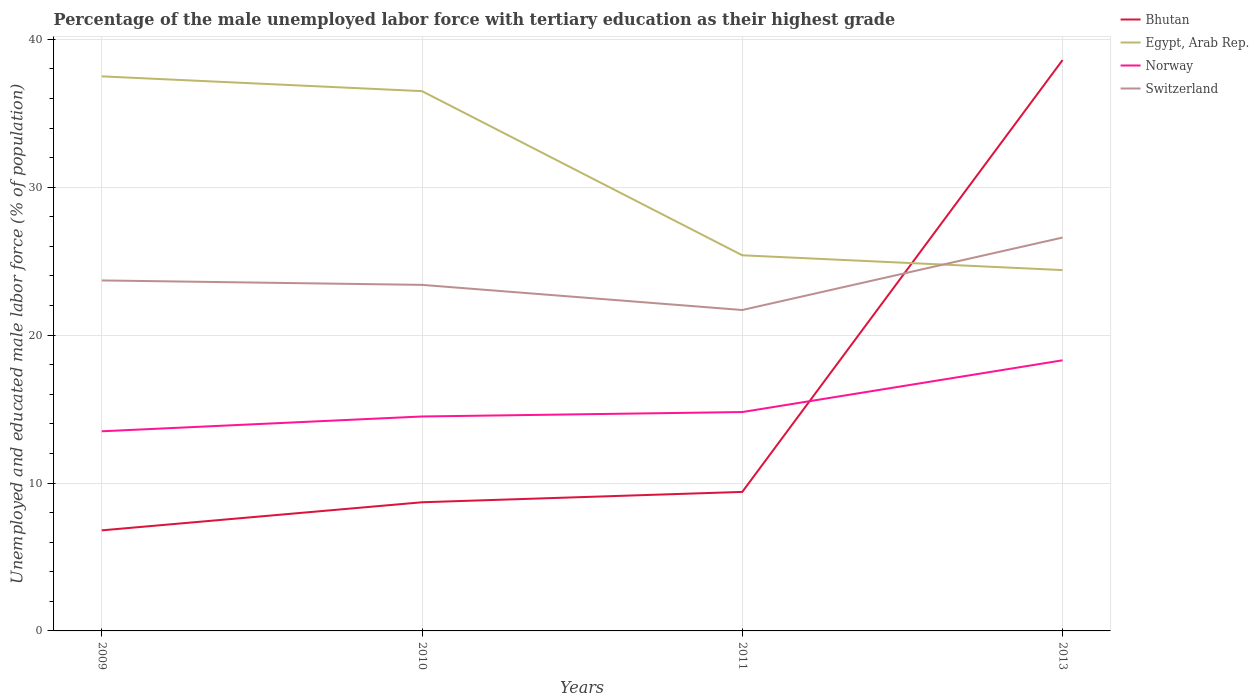How many different coloured lines are there?
Provide a short and direct response. 4. What is the total percentage of the unemployed male labor force with tertiary education in Norway in the graph?
Your answer should be very brief. -1. What is the difference between the highest and the second highest percentage of the unemployed male labor force with tertiary education in Bhutan?
Your response must be concise. 31.8. What is the difference between the highest and the lowest percentage of the unemployed male labor force with tertiary education in Norway?
Your response must be concise. 1. How many lines are there?
Ensure brevity in your answer.  4. What is the difference between two consecutive major ticks on the Y-axis?
Offer a terse response. 10. Are the values on the major ticks of Y-axis written in scientific E-notation?
Offer a very short reply. No. What is the title of the graph?
Provide a short and direct response. Percentage of the male unemployed labor force with tertiary education as their highest grade. Does "Peru" appear as one of the legend labels in the graph?
Provide a short and direct response. No. What is the label or title of the X-axis?
Provide a short and direct response. Years. What is the label or title of the Y-axis?
Keep it short and to the point. Unemployed and educated male labor force (% of population). What is the Unemployed and educated male labor force (% of population) of Bhutan in 2009?
Provide a succinct answer. 6.8. What is the Unemployed and educated male labor force (% of population) of Egypt, Arab Rep. in 2009?
Provide a short and direct response. 37.5. What is the Unemployed and educated male labor force (% of population) in Switzerland in 2009?
Offer a terse response. 23.7. What is the Unemployed and educated male labor force (% of population) of Bhutan in 2010?
Your answer should be compact. 8.7. What is the Unemployed and educated male labor force (% of population) in Egypt, Arab Rep. in 2010?
Offer a terse response. 36.5. What is the Unemployed and educated male labor force (% of population) in Switzerland in 2010?
Keep it short and to the point. 23.4. What is the Unemployed and educated male labor force (% of population) in Bhutan in 2011?
Ensure brevity in your answer.  9.4. What is the Unemployed and educated male labor force (% of population) in Egypt, Arab Rep. in 2011?
Keep it short and to the point. 25.4. What is the Unemployed and educated male labor force (% of population) of Norway in 2011?
Offer a terse response. 14.8. What is the Unemployed and educated male labor force (% of population) in Switzerland in 2011?
Keep it short and to the point. 21.7. What is the Unemployed and educated male labor force (% of population) in Bhutan in 2013?
Give a very brief answer. 38.6. What is the Unemployed and educated male labor force (% of population) in Egypt, Arab Rep. in 2013?
Provide a succinct answer. 24.4. What is the Unemployed and educated male labor force (% of population) of Norway in 2013?
Provide a short and direct response. 18.3. What is the Unemployed and educated male labor force (% of population) in Switzerland in 2013?
Provide a succinct answer. 26.6. Across all years, what is the maximum Unemployed and educated male labor force (% of population) of Bhutan?
Provide a succinct answer. 38.6. Across all years, what is the maximum Unemployed and educated male labor force (% of population) of Egypt, Arab Rep.?
Ensure brevity in your answer.  37.5. Across all years, what is the maximum Unemployed and educated male labor force (% of population) of Norway?
Your response must be concise. 18.3. Across all years, what is the maximum Unemployed and educated male labor force (% of population) of Switzerland?
Ensure brevity in your answer.  26.6. Across all years, what is the minimum Unemployed and educated male labor force (% of population) in Bhutan?
Your answer should be compact. 6.8. Across all years, what is the minimum Unemployed and educated male labor force (% of population) in Egypt, Arab Rep.?
Provide a succinct answer. 24.4. Across all years, what is the minimum Unemployed and educated male labor force (% of population) in Switzerland?
Make the answer very short. 21.7. What is the total Unemployed and educated male labor force (% of population) of Bhutan in the graph?
Give a very brief answer. 63.5. What is the total Unemployed and educated male labor force (% of population) of Egypt, Arab Rep. in the graph?
Offer a very short reply. 123.8. What is the total Unemployed and educated male labor force (% of population) of Norway in the graph?
Provide a short and direct response. 61.1. What is the total Unemployed and educated male labor force (% of population) in Switzerland in the graph?
Make the answer very short. 95.4. What is the difference between the Unemployed and educated male labor force (% of population) of Egypt, Arab Rep. in 2009 and that in 2010?
Ensure brevity in your answer.  1. What is the difference between the Unemployed and educated male labor force (% of population) in Norway in 2009 and that in 2010?
Make the answer very short. -1. What is the difference between the Unemployed and educated male labor force (% of population) in Switzerland in 2009 and that in 2010?
Provide a short and direct response. 0.3. What is the difference between the Unemployed and educated male labor force (% of population) in Bhutan in 2009 and that in 2011?
Offer a terse response. -2.6. What is the difference between the Unemployed and educated male labor force (% of population) of Norway in 2009 and that in 2011?
Provide a succinct answer. -1.3. What is the difference between the Unemployed and educated male labor force (% of population) in Switzerland in 2009 and that in 2011?
Your answer should be very brief. 2. What is the difference between the Unemployed and educated male labor force (% of population) of Bhutan in 2009 and that in 2013?
Offer a terse response. -31.8. What is the difference between the Unemployed and educated male labor force (% of population) of Norway in 2010 and that in 2011?
Offer a very short reply. -0.3. What is the difference between the Unemployed and educated male labor force (% of population) in Bhutan in 2010 and that in 2013?
Offer a terse response. -29.9. What is the difference between the Unemployed and educated male labor force (% of population) in Egypt, Arab Rep. in 2010 and that in 2013?
Keep it short and to the point. 12.1. What is the difference between the Unemployed and educated male labor force (% of population) of Norway in 2010 and that in 2013?
Ensure brevity in your answer.  -3.8. What is the difference between the Unemployed and educated male labor force (% of population) of Switzerland in 2010 and that in 2013?
Provide a short and direct response. -3.2. What is the difference between the Unemployed and educated male labor force (% of population) of Bhutan in 2011 and that in 2013?
Keep it short and to the point. -29.2. What is the difference between the Unemployed and educated male labor force (% of population) in Egypt, Arab Rep. in 2011 and that in 2013?
Offer a terse response. 1. What is the difference between the Unemployed and educated male labor force (% of population) in Switzerland in 2011 and that in 2013?
Keep it short and to the point. -4.9. What is the difference between the Unemployed and educated male labor force (% of population) in Bhutan in 2009 and the Unemployed and educated male labor force (% of population) in Egypt, Arab Rep. in 2010?
Ensure brevity in your answer.  -29.7. What is the difference between the Unemployed and educated male labor force (% of population) in Bhutan in 2009 and the Unemployed and educated male labor force (% of population) in Switzerland in 2010?
Your answer should be compact. -16.6. What is the difference between the Unemployed and educated male labor force (% of population) in Egypt, Arab Rep. in 2009 and the Unemployed and educated male labor force (% of population) in Norway in 2010?
Offer a very short reply. 23. What is the difference between the Unemployed and educated male labor force (% of population) in Egypt, Arab Rep. in 2009 and the Unemployed and educated male labor force (% of population) in Switzerland in 2010?
Your response must be concise. 14.1. What is the difference between the Unemployed and educated male labor force (% of population) in Norway in 2009 and the Unemployed and educated male labor force (% of population) in Switzerland in 2010?
Give a very brief answer. -9.9. What is the difference between the Unemployed and educated male labor force (% of population) of Bhutan in 2009 and the Unemployed and educated male labor force (% of population) of Egypt, Arab Rep. in 2011?
Keep it short and to the point. -18.6. What is the difference between the Unemployed and educated male labor force (% of population) in Bhutan in 2009 and the Unemployed and educated male labor force (% of population) in Switzerland in 2011?
Make the answer very short. -14.9. What is the difference between the Unemployed and educated male labor force (% of population) of Egypt, Arab Rep. in 2009 and the Unemployed and educated male labor force (% of population) of Norway in 2011?
Provide a short and direct response. 22.7. What is the difference between the Unemployed and educated male labor force (% of population) in Bhutan in 2009 and the Unemployed and educated male labor force (% of population) in Egypt, Arab Rep. in 2013?
Give a very brief answer. -17.6. What is the difference between the Unemployed and educated male labor force (% of population) in Bhutan in 2009 and the Unemployed and educated male labor force (% of population) in Norway in 2013?
Your response must be concise. -11.5. What is the difference between the Unemployed and educated male labor force (% of population) of Bhutan in 2009 and the Unemployed and educated male labor force (% of population) of Switzerland in 2013?
Make the answer very short. -19.8. What is the difference between the Unemployed and educated male labor force (% of population) in Egypt, Arab Rep. in 2009 and the Unemployed and educated male labor force (% of population) in Norway in 2013?
Give a very brief answer. 19.2. What is the difference between the Unemployed and educated male labor force (% of population) in Norway in 2009 and the Unemployed and educated male labor force (% of population) in Switzerland in 2013?
Your answer should be very brief. -13.1. What is the difference between the Unemployed and educated male labor force (% of population) of Bhutan in 2010 and the Unemployed and educated male labor force (% of population) of Egypt, Arab Rep. in 2011?
Ensure brevity in your answer.  -16.7. What is the difference between the Unemployed and educated male labor force (% of population) of Bhutan in 2010 and the Unemployed and educated male labor force (% of population) of Norway in 2011?
Offer a very short reply. -6.1. What is the difference between the Unemployed and educated male labor force (% of population) of Egypt, Arab Rep. in 2010 and the Unemployed and educated male labor force (% of population) of Norway in 2011?
Provide a succinct answer. 21.7. What is the difference between the Unemployed and educated male labor force (% of population) of Norway in 2010 and the Unemployed and educated male labor force (% of population) of Switzerland in 2011?
Offer a very short reply. -7.2. What is the difference between the Unemployed and educated male labor force (% of population) in Bhutan in 2010 and the Unemployed and educated male labor force (% of population) in Egypt, Arab Rep. in 2013?
Give a very brief answer. -15.7. What is the difference between the Unemployed and educated male labor force (% of population) in Bhutan in 2010 and the Unemployed and educated male labor force (% of population) in Norway in 2013?
Keep it short and to the point. -9.6. What is the difference between the Unemployed and educated male labor force (% of population) of Bhutan in 2010 and the Unemployed and educated male labor force (% of population) of Switzerland in 2013?
Your answer should be compact. -17.9. What is the difference between the Unemployed and educated male labor force (% of population) of Egypt, Arab Rep. in 2010 and the Unemployed and educated male labor force (% of population) of Norway in 2013?
Make the answer very short. 18.2. What is the difference between the Unemployed and educated male labor force (% of population) of Egypt, Arab Rep. in 2010 and the Unemployed and educated male labor force (% of population) of Switzerland in 2013?
Offer a very short reply. 9.9. What is the difference between the Unemployed and educated male labor force (% of population) in Bhutan in 2011 and the Unemployed and educated male labor force (% of population) in Egypt, Arab Rep. in 2013?
Your response must be concise. -15. What is the difference between the Unemployed and educated male labor force (% of population) in Bhutan in 2011 and the Unemployed and educated male labor force (% of population) in Norway in 2013?
Ensure brevity in your answer.  -8.9. What is the difference between the Unemployed and educated male labor force (% of population) of Bhutan in 2011 and the Unemployed and educated male labor force (% of population) of Switzerland in 2013?
Your answer should be very brief. -17.2. What is the difference between the Unemployed and educated male labor force (% of population) in Egypt, Arab Rep. in 2011 and the Unemployed and educated male labor force (% of population) in Norway in 2013?
Provide a succinct answer. 7.1. What is the average Unemployed and educated male labor force (% of population) in Bhutan per year?
Provide a succinct answer. 15.88. What is the average Unemployed and educated male labor force (% of population) in Egypt, Arab Rep. per year?
Offer a very short reply. 30.95. What is the average Unemployed and educated male labor force (% of population) of Norway per year?
Provide a short and direct response. 15.28. What is the average Unemployed and educated male labor force (% of population) of Switzerland per year?
Provide a short and direct response. 23.85. In the year 2009, what is the difference between the Unemployed and educated male labor force (% of population) of Bhutan and Unemployed and educated male labor force (% of population) of Egypt, Arab Rep.?
Offer a very short reply. -30.7. In the year 2009, what is the difference between the Unemployed and educated male labor force (% of population) of Bhutan and Unemployed and educated male labor force (% of population) of Switzerland?
Your response must be concise. -16.9. In the year 2009, what is the difference between the Unemployed and educated male labor force (% of population) in Egypt, Arab Rep. and Unemployed and educated male labor force (% of population) in Norway?
Ensure brevity in your answer.  24. In the year 2009, what is the difference between the Unemployed and educated male labor force (% of population) of Egypt, Arab Rep. and Unemployed and educated male labor force (% of population) of Switzerland?
Give a very brief answer. 13.8. In the year 2010, what is the difference between the Unemployed and educated male labor force (% of population) of Bhutan and Unemployed and educated male labor force (% of population) of Egypt, Arab Rep.?
Offer a terse response. -27.8. In the year 2010, what is the difference between the Unemployed and educated male labor force (% of population) of Bhutan and Unemployed and educated male labor force (% of population) of Norway?
Offer a very short reply. -5.8. In the year 2010, what is the difference between the Unemployed and educated male labor force (% of population) of Bhutan and Unemployed and educated male labor force (% of population) of Switzerland?
Offer a very short reply. -14.7. In the year 2011, what is the difference between the Unemployed and educated male labor force (% of population) in Bhutan and Unemployed and educated male labor force (% of population) in Egypt, Arab Rep.?
Your answer should be very brief. -16. In the year 2011, what is the difference between the Unemployed and educated male labor force (% of population) of Bhutan and Unemployed and educated male labor force (% of population) of Norway?
Offer a very short reply. -5.4. In the year 2011, what is the difference between the Unemployed and educated male labor force (% of population) in Bhutan and Unemployed and educated male labor force (% of population) in Switzerland?
Keep it short and to the point. -12.3. In the year 2011, what is the difference between the Unemployed and educated male labor force (% of population) in Norway and Unemployed and educated male labor force (% of population) in Switzerland?
Offer a very short reply. -6.9. In the year 2013, what is the difference between the Unemployed and educated male labor force (% of population) of Bhutan and Unemployed and educated male labor force (% of population) of Egypt, Arab Rep.?
Ensure brevity in your answer.  14.2. In the year 2013, what is the difference between the Unemployed and educated male labor force (% of population) of Bhutan and Unemployed and educated male labor force (% of population) of Norway?
Your answer should be very brief. 20.3. What is the ratio of the Unemployed and educated male labor force (% of population) in Bhutan in 2009 to that in 2010?
Your answer should be very brief. 0.78. What is the ratio of the Unemployed and educated male labor force (% of population) of Egypt, Arab Rep. in 2009 to that in 2010?
Your answer should be compact. 1.03. What is the ratio of the Unemployed and educated male labor force (% of population) in Norway in 2009 to that in 2010?
Provide a short and direct response. 0.93. What is the ratio of the Unemployed and educated male labor force (% of population) of Switzerland in 2009 to that in 2010?
Provide a short and direct response. 1.01. What is the ratio of the Unemployed and educated male labor force (% of population) in Bhutan in 2009 to that in 2011?
Your answer should be compact. 0.72. What is the ratio of the Unemployed and educated male labor force (% of population) of Egypt, Arab Rep. in 2009 to that in 2011?
Make the answer very short. 1.48. What is the ratio of the Unemployed and educated male labor force (% of population) of Norway in 2009 to that in 2011?
Provide a succinct answer. 0.91. What is the ratio of the Unemployed and educated male labor force (% of population) of Switzerland in 2009 to that in 2011?
Offer a terse response. 1.09. What is the ratio of the Unemployed and educated male labor force (% of population) of Bhutan in 2009 to that in 2013?
Your response must be concise. 0.18. What is the ratio of the Unemployed and educated male labor force (% of population) of Egypt, Arab Rep. in 2009 to that in 2013?
Your answer should be very brief. 1.54. What is the ratio of the Unemployed and educated male labor force (% of population) of Norway in 2009 to that in 2013?
Keep it short and to the point. 0.74. What is the ratio of the Unemployed and educated male labor force (% of population) of Switzerland in 2009 to that in 2013?
Ensure brevity in your answer.  0.89. What is the ratio of the Unemployed and educated male labor force (% of population) in Bhutan in 2010 to that in 2011?
Offer a very short reply. 0.93. What is the ratio of the Unemployed and educated male labor force (% of population) of Egypt, Arab Rep. in 2010 to that in 2011?
Your answer should be very brief. 1.44. What is the ratio of the Unemployed and educated male labor force (% of population) in Norway in 2010 to that in 2011?
Your answer should be compact. 0.98. What is the ratio of the Unemployed and educated male labor force (% of population) of Switzerland in 2010 to that in 2011?
Provide a succinct answer. 1.08. What is the ratio of the Unemployed and educated male labor force (% of population) of Bhutan in 2010 to that in 2013?
Provide a short and direct response. 0.23. What is the ratio of the Unemployed and educated male labor force (% of population) of Egypt, Arab Rep. in 2010 to that in 2013?
Your answer should be compact. 1.5. What is the ratio of the Unemployed and educated male labor force (% of population) in Norway in 2010 to that in 2013?
Your answer should be compact. 0.79. What is the ratio of the Unemployed and educated male labor force (% of population) in Switzerland in 2010 to that in 2013?
Your answer should be very brief. 0.88. What is the ratio of the Unemployed and educated male labor force (% of population) in Bhutan in 2011 to that in 2013?
Provide a short and direct response. 0.24. What is the ratio of the Unemployed and educated male labor force (% of population) in Egypt, Arab Rep. in 2011 to that in 2013?
Your response must be concise. 1.04. What is the ratio of the Unemployed and educated male labor force (% of population) in Norway in 2011 to that in 2013?
Your answer should be very brief. 0.81. What is the ratio of the Unemployed and educated male labor force (% of population) in Switzerland in 2011 to that in 2013?
Your answer should be very brief. 0.82. What is the difference between the highest and the second highest Unemployed and educated male labor force (% of population) in Bhutan?
Give a very brief answer. 29.2. What is the difference between the highest and the second highest Unemployed and educated male labor force (% of population) in Egypt, Arab Rep.?
Provide a short and direct response. 1. What is the difference between the highest and the second highest Unemployed and educated male labor force (% of population) of Switzerland?
Offer a very short reply. 2.9. What is the difference between the highest and the lowest Unemployed and educated male labor force (% of population) in Bhutan?
Keep it short and to the point. 31.8. What is the difference between the highest and the lowest Unemployed and educated male labor force (% of population) of Norway?
Make the answer very short. 4.8. 